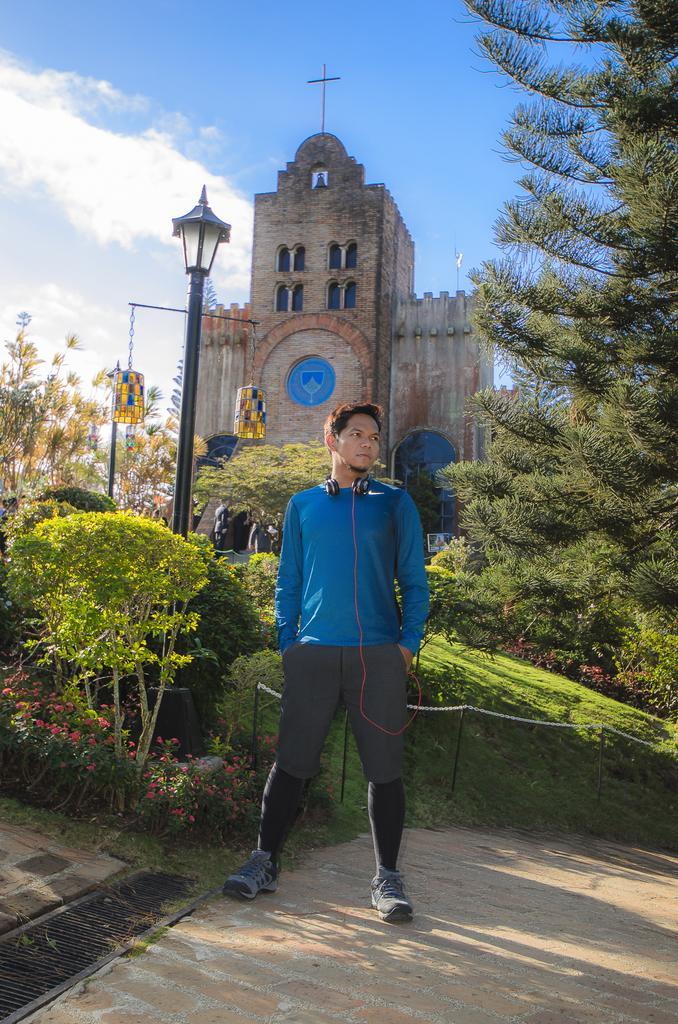How would you summarize this image in a sentence or two? In this picture there is a man with blue t-shirt is standing. At the back there is a building and there are trees and street lights and there is a bell on the building. At the top there is sky and there are clouds. At the bottom there are plants and flowers and there is grass and there is a railing on the ground and there is a pavement. 